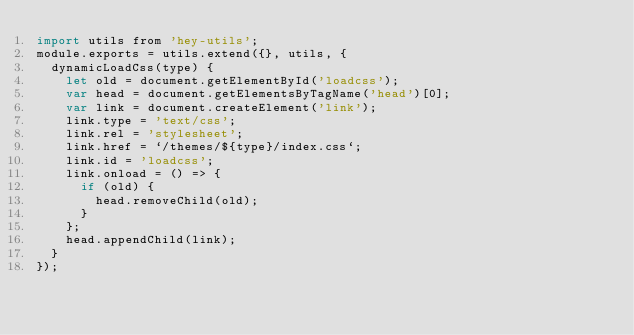<code> <loc_0><loc_0><loc_500><loc_500><_JavaScript_>import utils from 'hey-utils';
module.exports = utils.extend({}, utils, {
  dynamicLoadCss(type) {
    let old = document.getElementById('loadcss');
    var head = document.getElementsByTagName('head')[0];
    var link = document.createElement('link');
    link.type = 'text/css';
    link.rel = 'stylesheet';
    link.href = `/themes/${type}/index.css`;
    link.id = 'loadcss';
    link.onload = () => {
      if (old) {
        head.removeChild(old);
      }
    };
    head.appendChild(link);
  }
});
</code> 